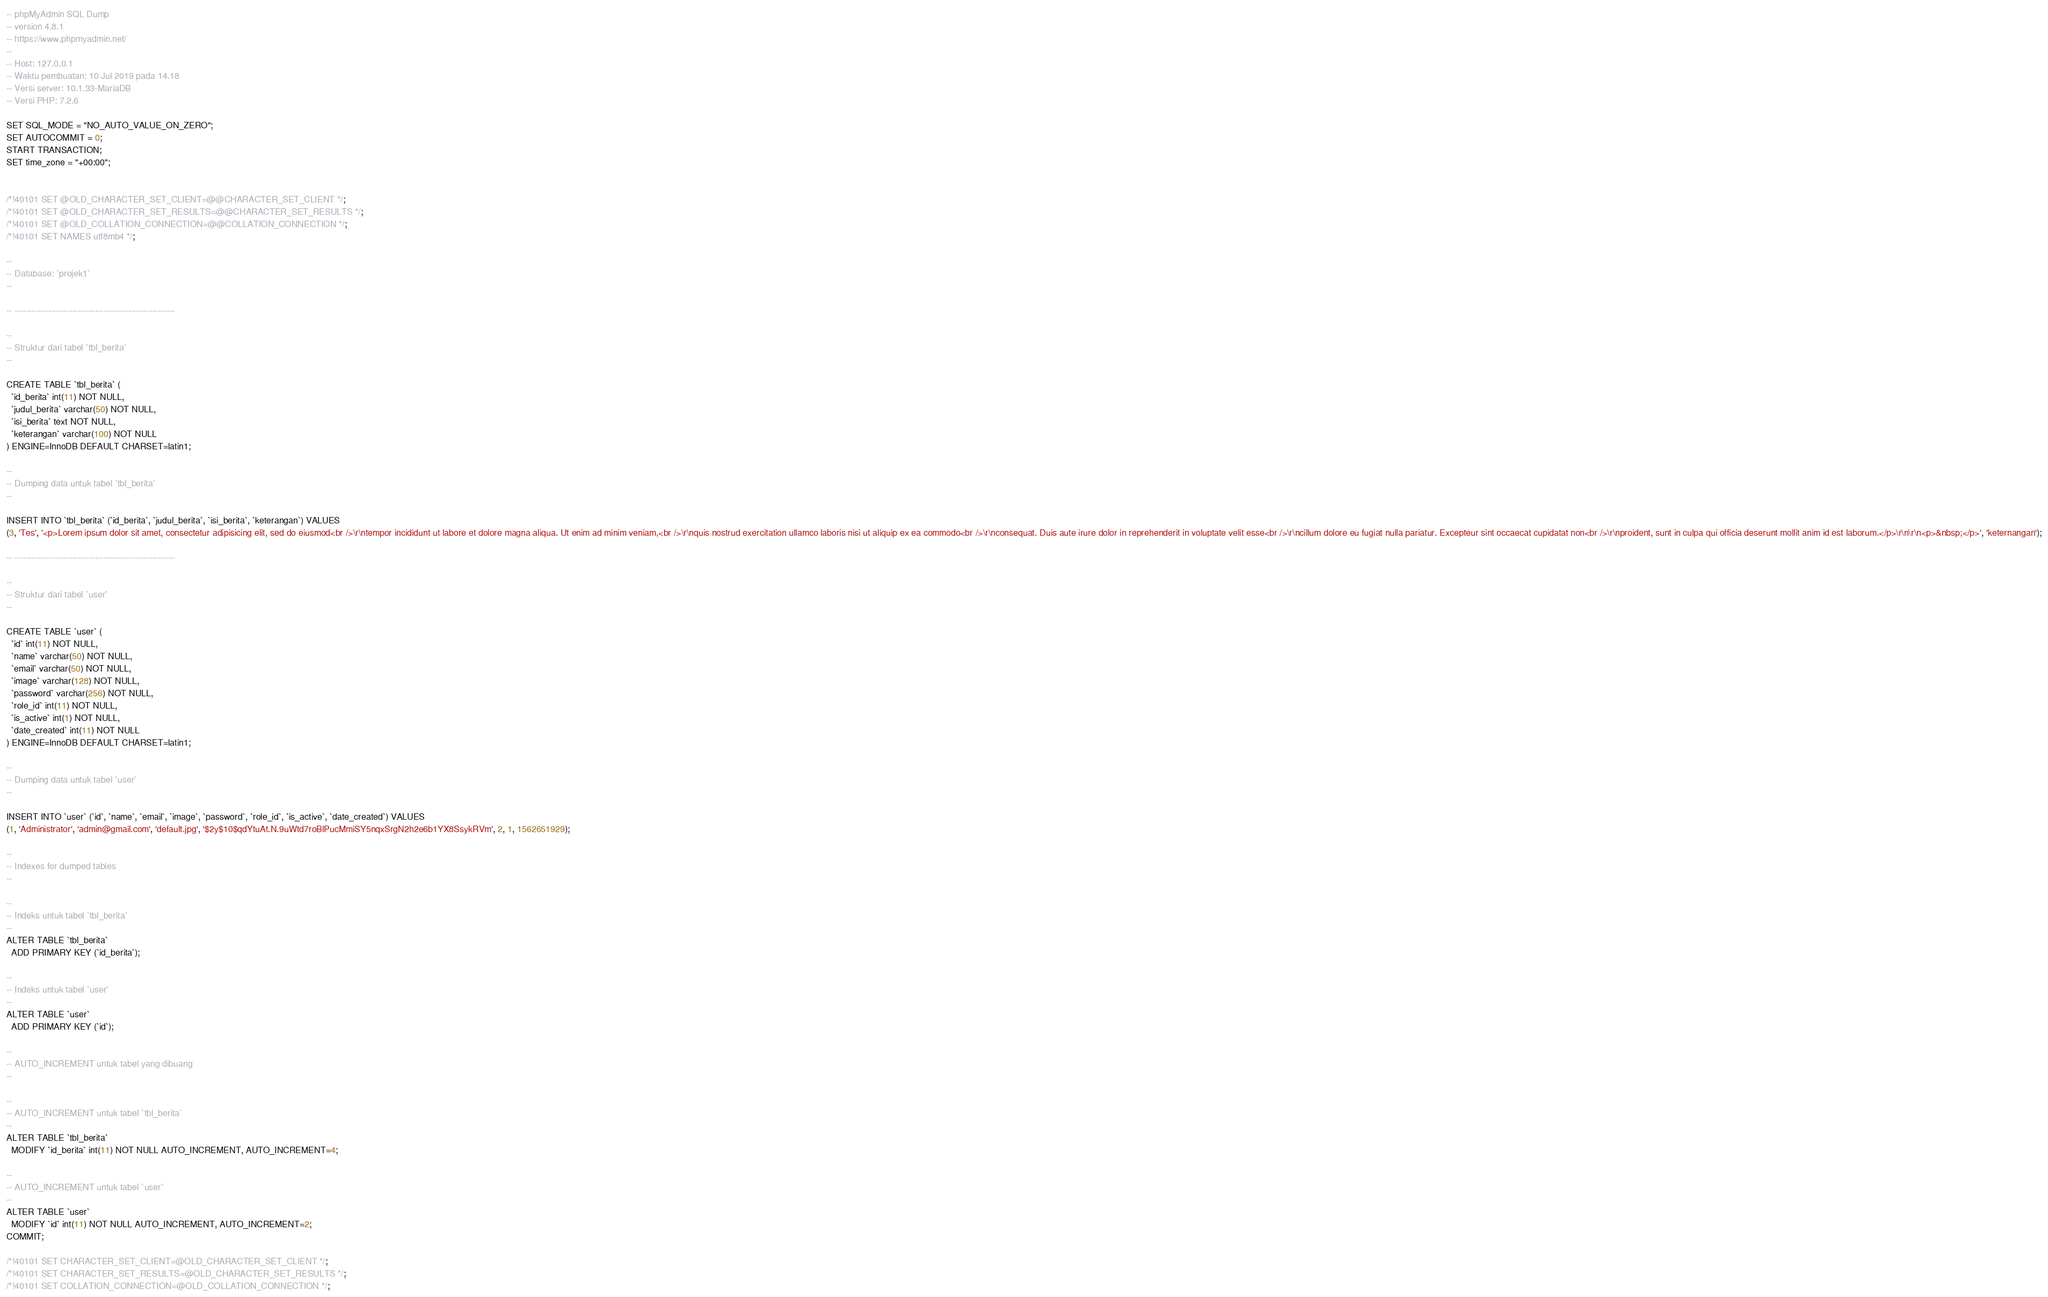Convert code to text. <code><loc_0><loc_0><loc_500><loc_500><_SQL_>-- phpMyAdmin SQL Dump
-- version 4.8.1
-- https://www.phpmyadmin.net/
--
-- Host: 127.0.0.1
-- Waktu pembuatan: 10 Jul 2019 pada 14.18
-- Versi server: 10.1.33-MariaDB
-- Versi PHP: 7.2.6

SET SQL_MODE = "NO_AUTO_VALUE_ON_ZERO";
SET AUTOCOMMIT = 0;
START TRANSACTION;
SET time_zone = "+00:00";


/*!40101 SET @OLD_CHARACTER_SET_CLIENT=@@CHARACTER_SET_CLIENT */;
/*!40101 SET @OLD_CHARACTER_SET_RESULTS=@@CHARACTER_SET_RESULTS */;
/*!40101 SET @OLD_COLLATION_CONNECTION=@@COLLATION_CONNECTION */;
/*!40101 SET NAMES utf8mb4 */;

--
-- Database: `projek1`
--

-- --------------------------------------------------------

--
-- Struktur dari tabel `tbl_berita`
--

CREATE TABLE `tbl_berita` (
  `id_berita` int(11) NOT NULL,
  `judul_berita` varchar(50) NOT NULL,
  `isi_berita` text NOT NULL,
  `keterangan` varchar(100) NOT NULL
) ENGINE=InnoDB DEFAULT CHARSET=latin1;

--
-- Dumping data untuk tabel `tbl_berita`
--

INSERT INTO `tbl_berita` (`id_berita`, `judul_berita`, `isi_berita`, `keterangan`) VALUES
(3, 'Tes', '<p>Lorem ipsum dolor sit amet, consectetur adipisicing elit, sed do eiusmod<br />\r\ntempor incididunt ut labore et dolore magna aliqua. Ut enim ad minim veniam,<br />\r\nquis nostrud exercitation ullamco laboris nisi ut aliquip ex ea commodo<br />\r\nconsequat. Duis aute irure dolor in reprehenderit in voluptate velit esse<br />\r\ncillum dolore eu fugiat nulla pariatur. Excepteur sint occaecat cupidatat non<br />\r\nproident, sunt in culpa qui officia deserunt mollit anim id est laborum.</p>\r\n\r\n<p>&nbsp;</p>', 'keternangan');

-- --------------------------------------------------------

--
-- Struktur dari tabel `user`
--

CREATE TABLE `user` (
  `id` int(11) NOT NULL,
  `name` varchar(50) NOT NULL,
  `email` varchar(50) NOT NULL,
  `image` varchar(128) NOT NULL,
  `password` varchar(256) NOT NULL,
  `role_id` int(11) NOT NULL,
  `is_active` int(1) NOT NULL,
  `date_created` int(11) NOT NULL
) ENGINE=InnoDB DEFAULT CHARSET=latin1;

--
-- Dumping data untuk tabel `user`
--

INSERT INTO `user` (`id`, `name`, `email`, `image`, `password`, `role_id`, `is_active`, `date_created`) VALUES
(1, 'Administrator', 'admin@gmail.com', 'default.jpg', '$2y$10$qdYtuAt.N.9uWtd7roBlPucMmiSY5nqxSrgN2h2e6b1YX8SsykRVm', 2, 1, 1562651929);

--
-- Indexes for dumped tables
--

--
-- Indeks untuk tabel `tbl_berita`
--
ALTER TABLE `tbl_berita`
  ADD PRIMARY KEY (`id_berita`);

--
-- Indeks untuk tabel `user`
--
ALTER TABLE `user`
  ADD PRIMARY KEY (`id`);

--
-- AUTO_INCREMENT untuk tabel yang dibuang
--

--
-- AUTO_INCREMENT untuk tabel `tbl_berita`
--
ALTER TABLE `tbl_berita`
  MODIFY `id_berita` int(11) NOT NULL AUTO_INCREMENT, AUTO_INCREMENT=4;

--
-- AUTO_INCREMENT untuk tabel `user`
--
ALTER TABLE `user`
  MODIFY `id` int(11) NOT NULL AUTO_INCREMENT, AUTO_INCREMENT=2;
COMMIT;

/*!40101 SET CHARACTER_SET_CLIENT=@OLD_CHARACTER_SET_CLIENT */;
/*!40101 SET CHARACTER_SET_RESULTS=@OLD_CHARACTER_SET_RESULTS */;
/*!40101 SET COLLATION_CONNECTION=@OLD_COLLATION_CONNECTION */;
</code> 